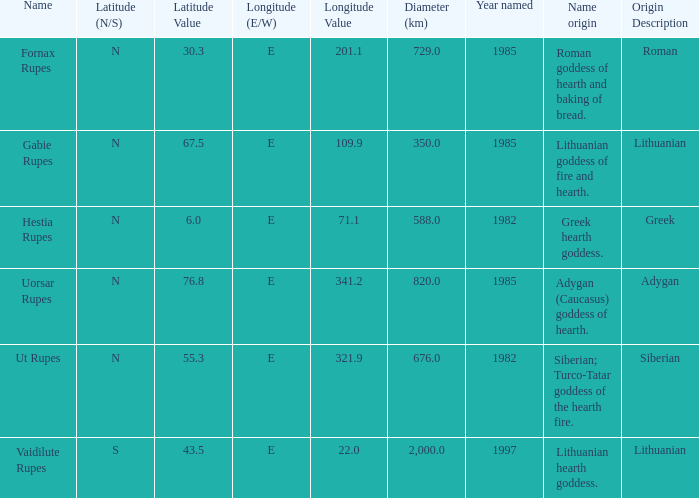Give me the full table as a dictionary. {'header': ['Name', 'Latitude (N/S)', 'Latitude Value', 'Longitude (E/W)', 'Longitude Value', 'Diameter (km)', 'Year named', 'Name origin', 'Origin Description'], 'rows': [['Fornax Rupes', 'N', '30.3', 'E', '201.1', '729.0', '1985', 'Roman goddess of hearth and baking of bread.', 'Roman'], ['Gabie Rupes', 'N', '67.5', 'E', '109.9', '350.0', '1985', 'Lithuanian goddess of fire and hearth.', 'Lithuanian'], ['Hestia Rupes', 'N', '6.0', 'E', '71.1', '588.0', '1982', 'Greek hearth goddess.', 'Greek'], ['Uorsar Rupes', 'N', '76.8', 'E', '341.2', '820.0', '1985', 'Adygan (Caucasus) goddess of hearth.', 'Adygan'], ['Ut Rupes', 'N', '55.3', 'E', '321.9', '676.0', '1982', 'Siberian; Turco-Tatar goddess of the hearth fire.', 'Siberian'], ['Vaidilute Rupes', 'S', '43.5', 'E', '22.0', '2,000.0', '1997', 'Lithuanian hearth goddess.', 'Lithuanian']]} At a latitude of 7 Greek hearth goddess. 